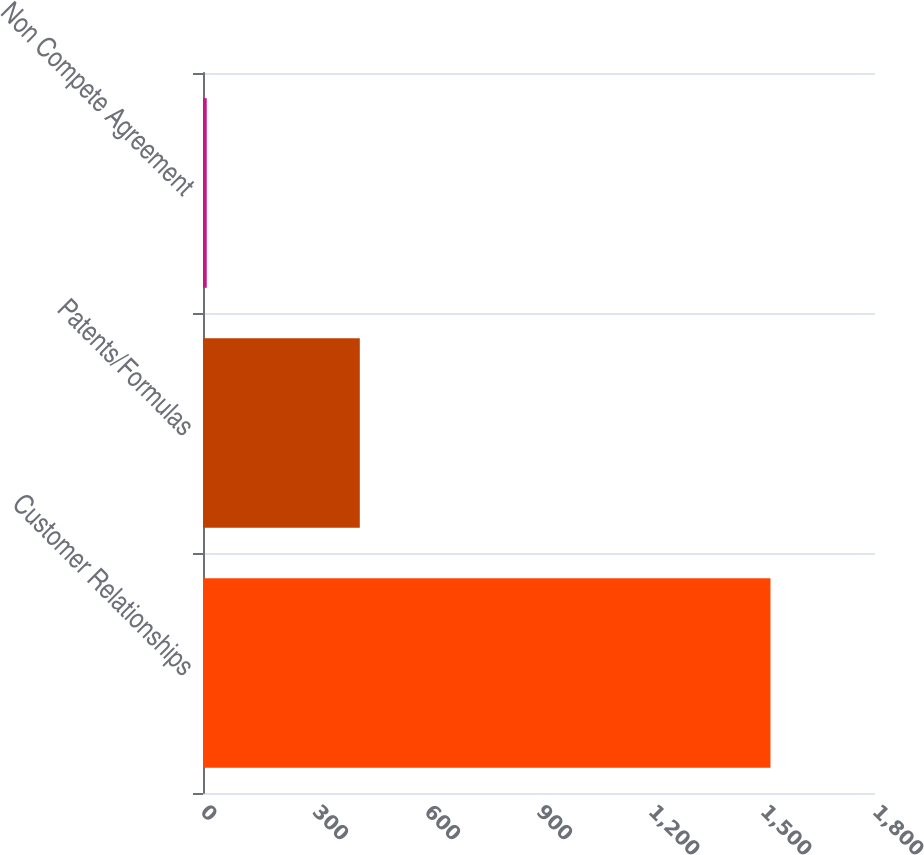<chart> <loc_0><loc_0><loc_500><loc_500><bar_chart><fcel>Customer Relationships<fcel>Patents/Formulas<fcel>Non Compete Agreement<nl><fcel>1520<fcel>420<fcel>10<nl></chart> 